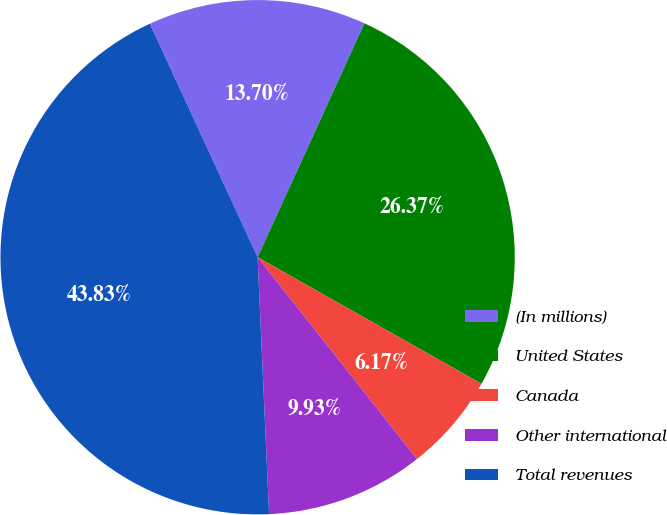<chart> <loc_0><loc_0><loc_500><loc_500><pie_chart><fcel>(In millions)<fcel>United States<fcel>Canada<fcel>Other international<fcel>Total revenues<nl><fcel>13.7%<fcel>26.37%<fcel>6.17%<fcel>9.93%<fcel>43.83%<nl></chart> 